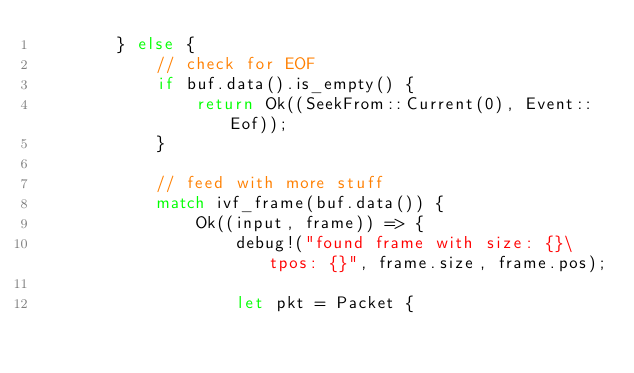Convert code to text. <code><loc_0><loc_0><loc_500><loc_500><_Rust_>        } else {
            // check for EOF
            if buf.data().is_empty() {
                return Ok((SeekFrom::Current(0), Event::Eof));
            }

            // feed with more stuff
            match ivf_frame(buf.data()) {
                Ok((input, frame)) => {
                    debug!("found frame with size: {}\tpos: {}", frame.size, frame.pos);

                    let pkt = Packet {</code> 